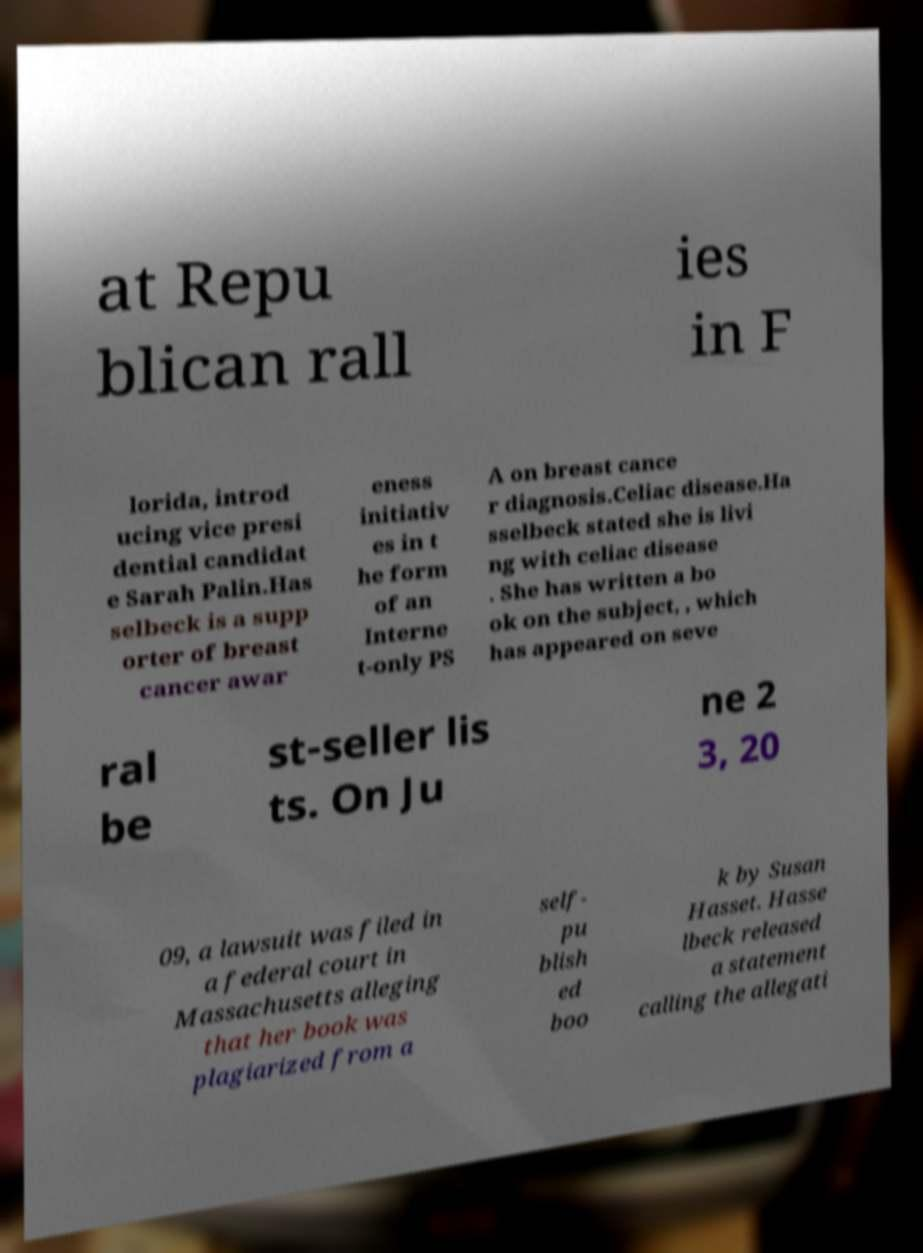Could you extract and type out the text from this image? at Repu blican rall ies in F lorida, introd ucing vice presi dential candidat e Sarah Palin.Has selbeck is a supp orter of breast cancer awar eness initiativ es in t he form of an Interne t-only PS A on breast cance r diagnosis.Celiac disease.Ha sselbeck stated she is livi ng with celiac disease . She has written a bo ok on the subject, , which has appeared on seve ral be st-seller lis ts. On Ju ne 2 3, 20 09, a lawsuit was filed in a federal court in Massachusetts alleging that her book was plagiarized from a self- pu blish ed boo k by Susan Hasset. Hasse lbeck released a statement calling the allegati 